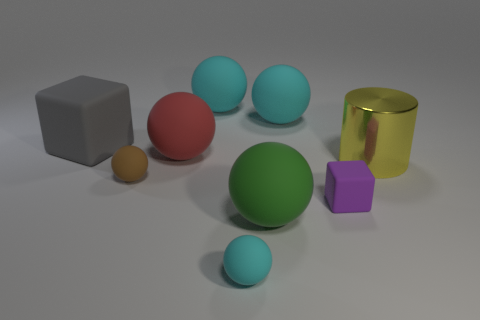Is there any other thing that is made of the same material as the big yellow cylinder?
Your answer should be very brief. No. What size is the red object that is the same shape as the green matte thing?
Keep it short and to the point. Large. Does the cyan thing that is in front of the gray matte block have the same material as the large cylinder?
Offer a terse response. No. There is a brown rubber object that is behind the tiny cyan rubber thing; is it the same shape as the cyan object in front of the tiny purple thing?
Offer a very short reply. Yes. There is a small thing on the right side of the big green object; what is it made of?
Your response must be concise. Rubber. How many objects are either big things that are to the right of the gray matte block or large green spheres?
Your response must be concise. 5. Are there an equal number of cyan matte spheres that are on the right side of the purple block and big green rubber things?
Your answer should be compact. No. Is the yellow shiny cylinder the same size as the brown sphere?
Provide a succinct answer. No. What is the color of the cube that is the same size as the yellow metal cylinder?
Provide a short and direct response. Gray. Do the metallic thing and the rubber block that is behind the cylinder have the same size?
Give a very brief answer. Yes. 